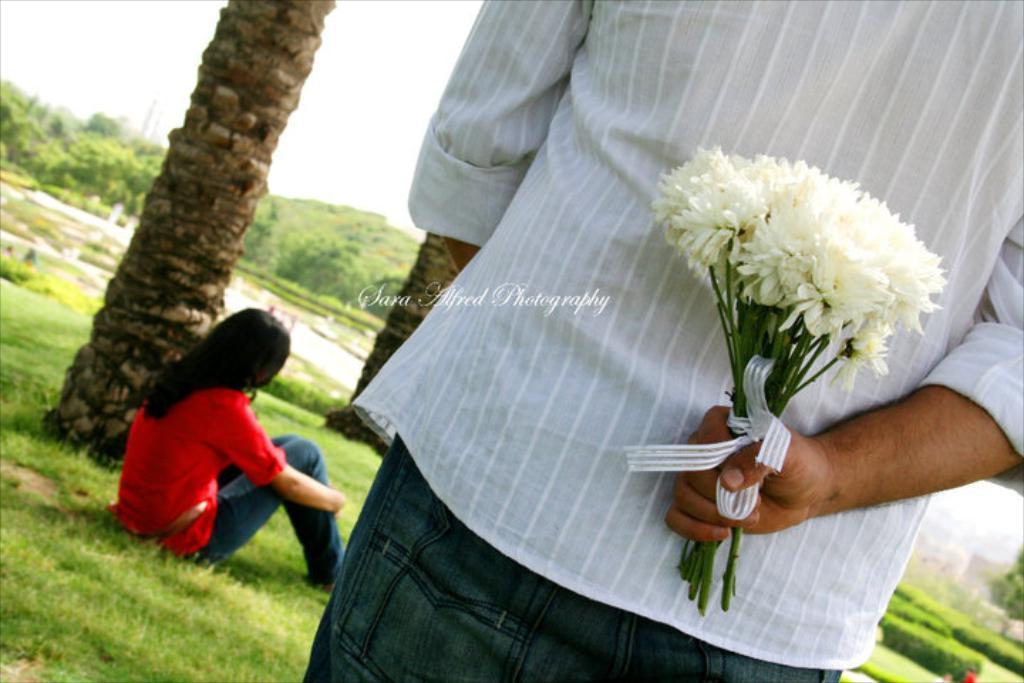Describe this image in one or two sentences. In this image we can see two persons, among them one person is standing and holding some flowers and the other person is sitting on the ground, we can see some trees, grass and the sky. 